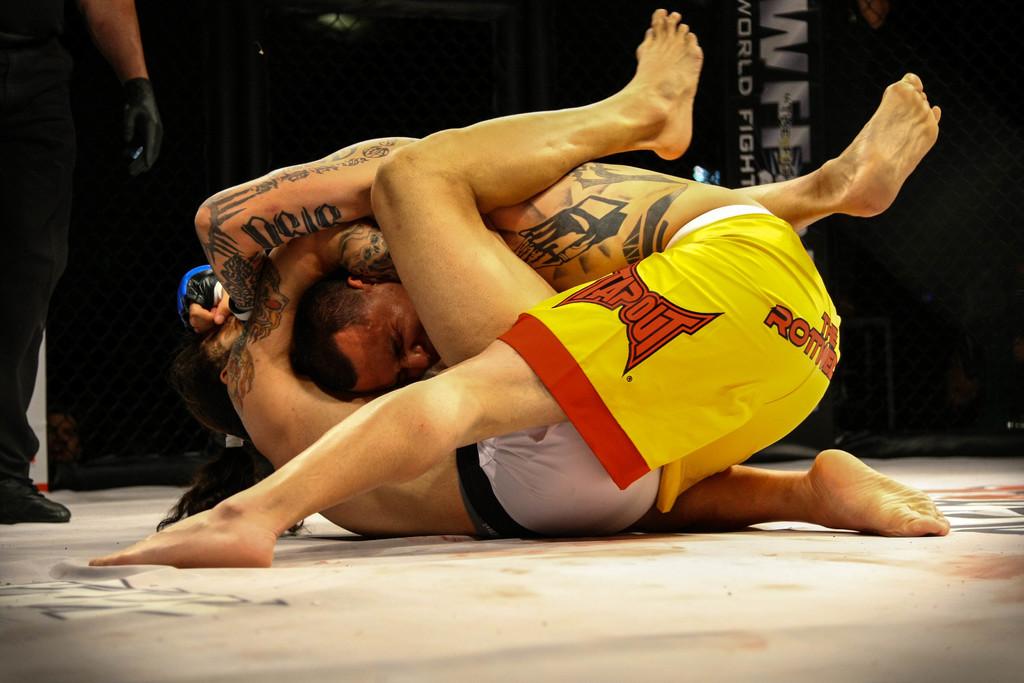What brand are the wrestler's yellow and red shorts?
Offer a terse response. Tapout. 